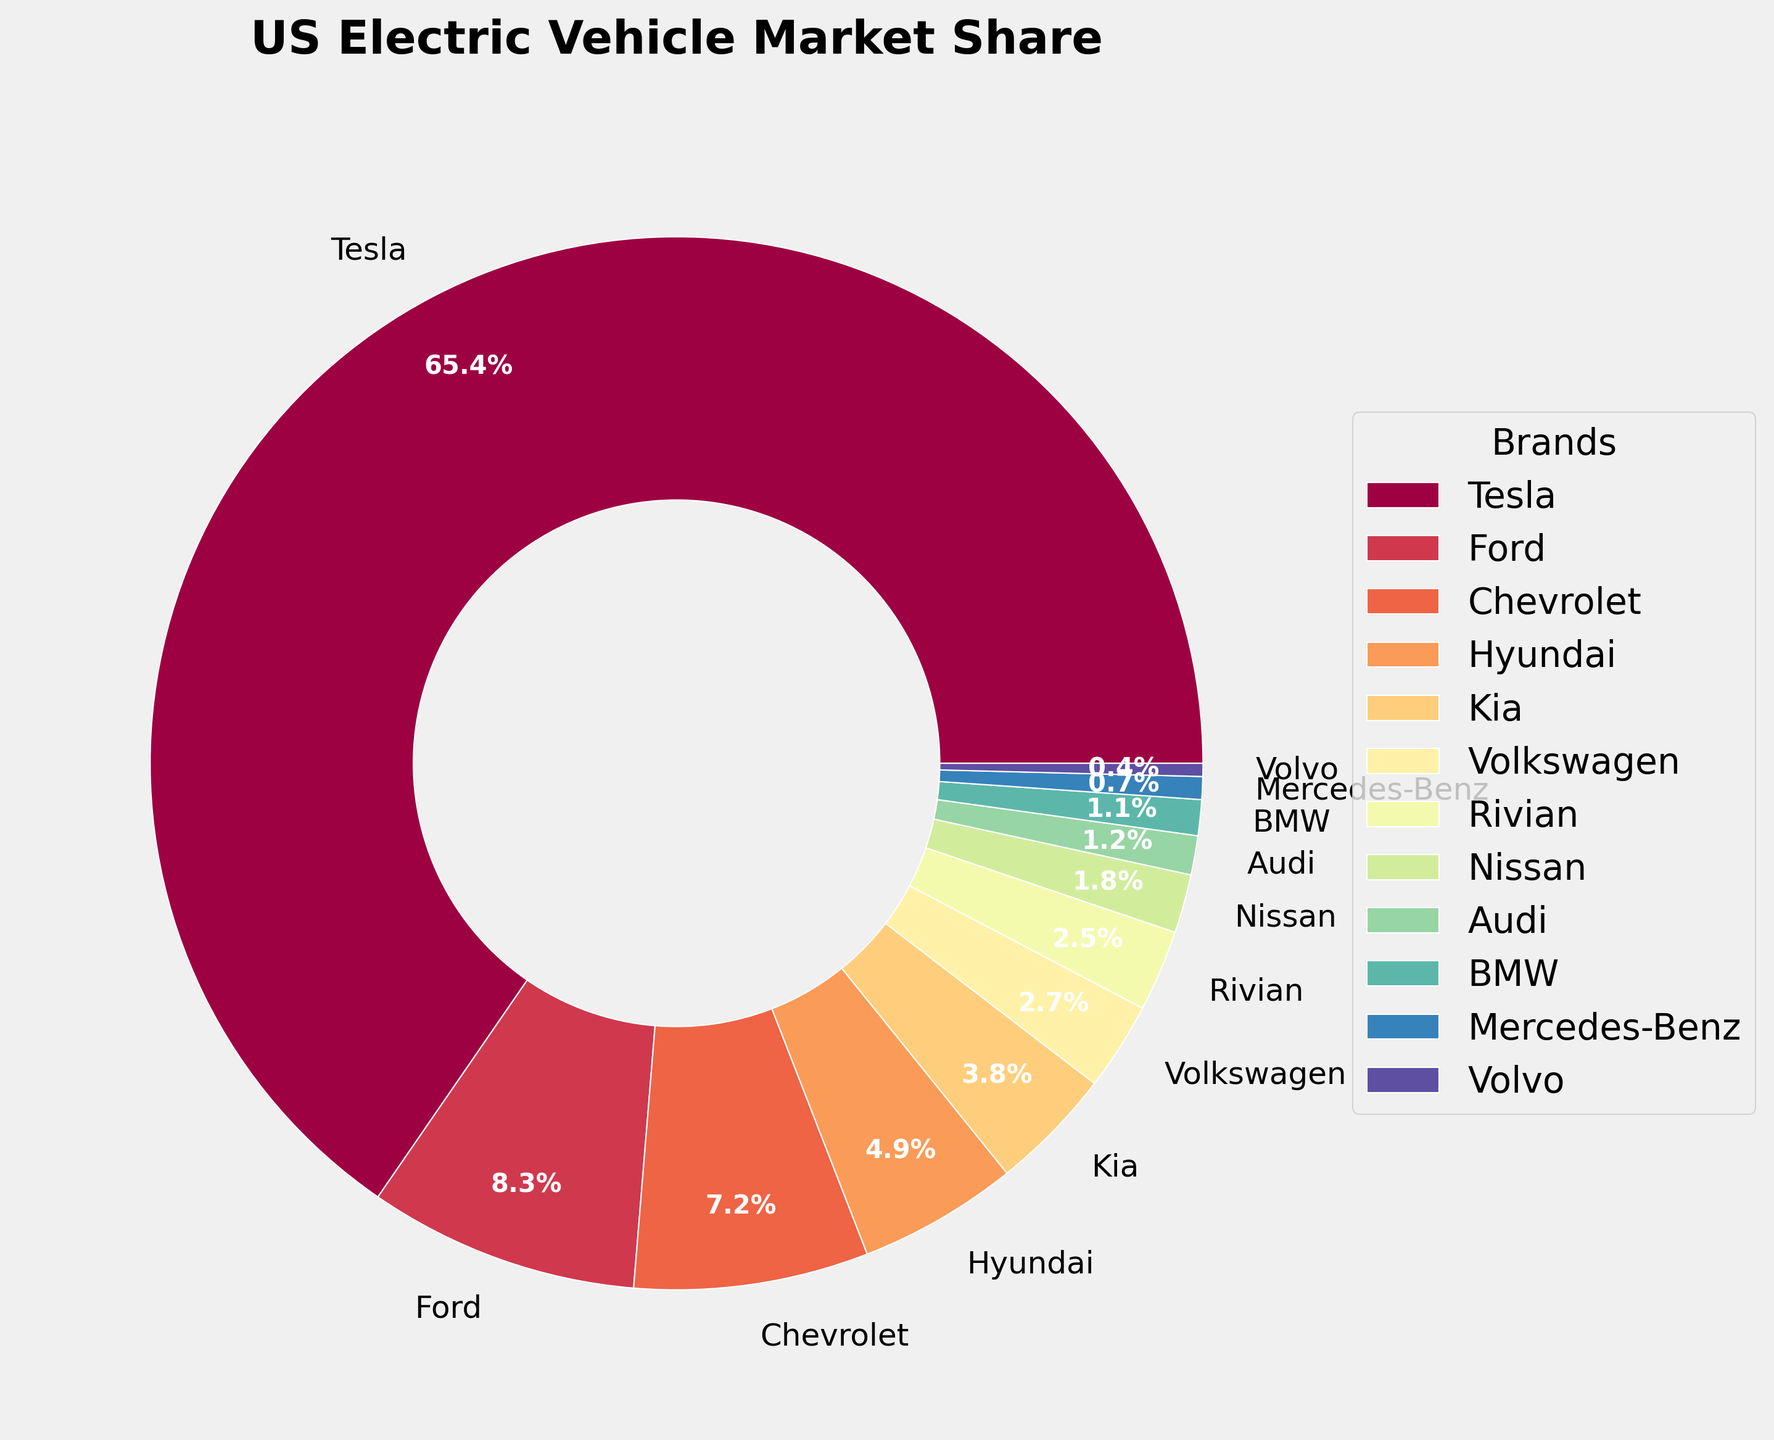Which brand has the largest market share in the US electric vehicle market? The figure shows a pie chart with market shares for each brand. Looking at the sizes of the slices, Tesla has the largest slice, over 65%.
Answer: Tesla Which two brands together make up less than 1% of the market? From the pie chart, BMW and Mercedes-Benz have the smallest slices, with each constituting 1.1% and 0.7%, which sum up to less than 1%.
Answer: Audi and Volvo How much larger is Tesla's market share compared to Ford's? Tesla's market share is 65.4%, and Ford's is 8.3%. The difference is calculated as 65.4% - 8.3% = 57.1%.
Answer: 57.1% Which brands each share more than 5% of the market? By analyzing the portions of the pie chart greater than 5%, Tesla, Ford, and Chevrolet each have market shares exceeding 5%.
Answer: Tesla, Ford, Chevrolet If Tesla's market share was split equally among Ford, Chevrolet, and Hyundai, what would be each of their new shares? Tesla's share is 65.4%. If this is equally divided among Ford (8.3%), Chevrolet (7.2%), and Hyundai (4.9%), each gets 65.4% / 3 = 21.8%. Add this to their original shares: 
Ford: 8.3% + 21.8% = 30.1% 
Chevrolet: 7.2% + 21.8% = 29.0% 
Hyundai: 4.9% + 21.8% = 26.7%
Answer: Ford: 30.1%, Chevrolet: 29.0%, Hyundai: 26.7% Which color represents Rivian in the pie chart? The pie chart uses the Spectral colormap which provides a gradient from different colors. According to the gradient pattern and ordering from the legend, Rivian is allocated a dark color, likely purple or deep blue based on its position.
Answer: Purple or deep blue What is the combined market share of Kia, Volkswagen, and Rivian? Adding their individual shares as shown in the pie chart: Kia (3.8%), Volkswagen (2.7%), and Rivian (2.5%). The total is 3.8% + 2.7% + 2.5% = 9.0%.
Answer: 9.0% How many brands hold less than 2% of the market each? Analyzing the pie chart, Nissan, Audi, BMW, Mercedes-Benz, and Volvo each hold less than 2%.
Answer: 5 brands 